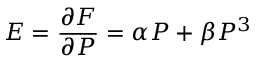Convert formula to latex. <formula><loc_0><loc_0><loc_500><loc_500>E = \frac { \partial F } { \partial P } = \alpha P + \beta P ^ { 3 }</formula> 